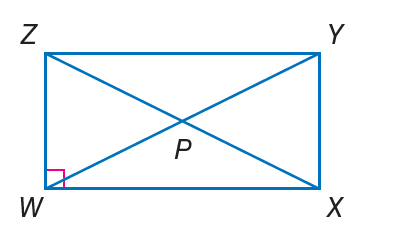Answer the mathemtical geometry problem and directly provide the correct option letter.
Question: If m \angle X Z Y = 3 x + 6 and m \angle X Z W = 5 x - 12, find m \angle Y X Z.
Choices: A: 12 B: 24 C: 48 D: 50 C 